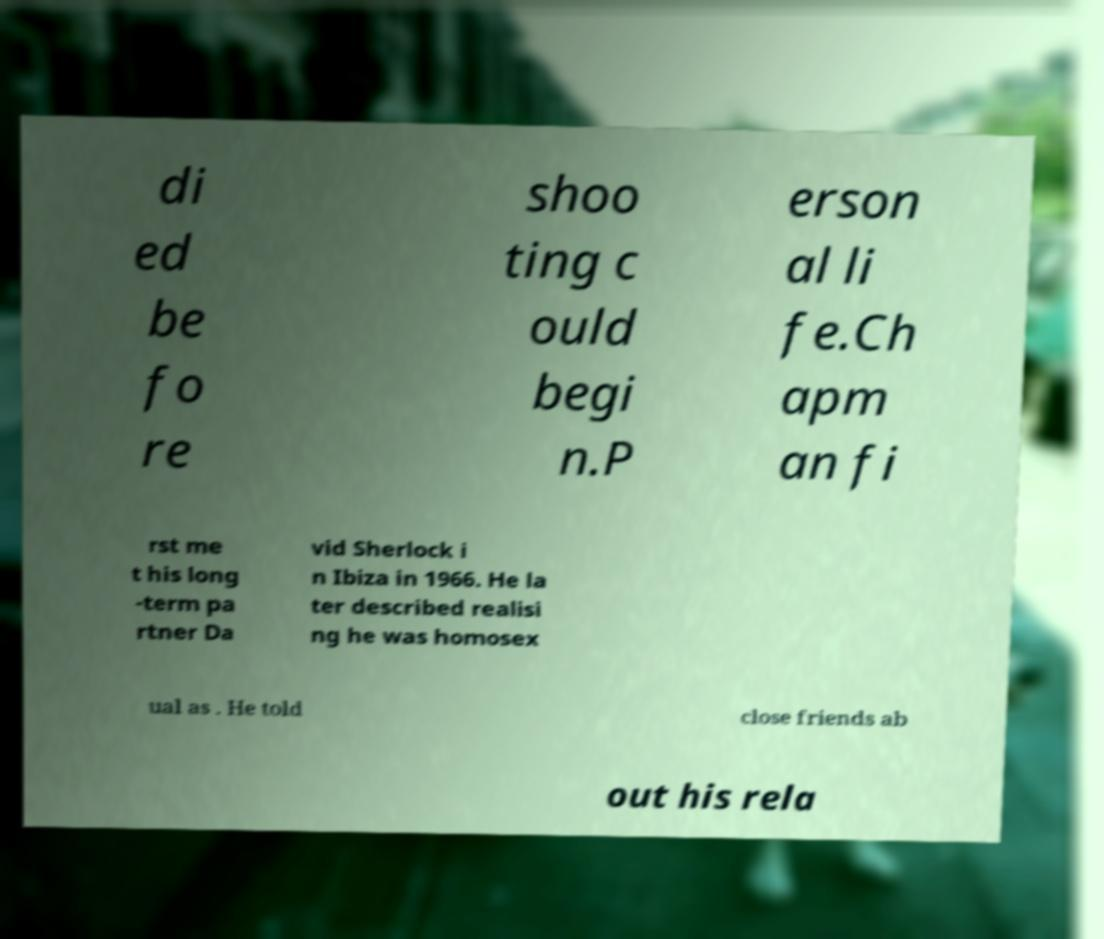For documentation purposes, I need the text within this image transcribed. Could you provide that? di ed be fo re shoo ting c ould begi n.P erson al li fe.Ch apm an fi rst me t his long -term pa rtner Da vid Sherlock i n Ibiza in 1966. He la ter described realisi ng he was homosex ual as . He told close friends ab out his rela 